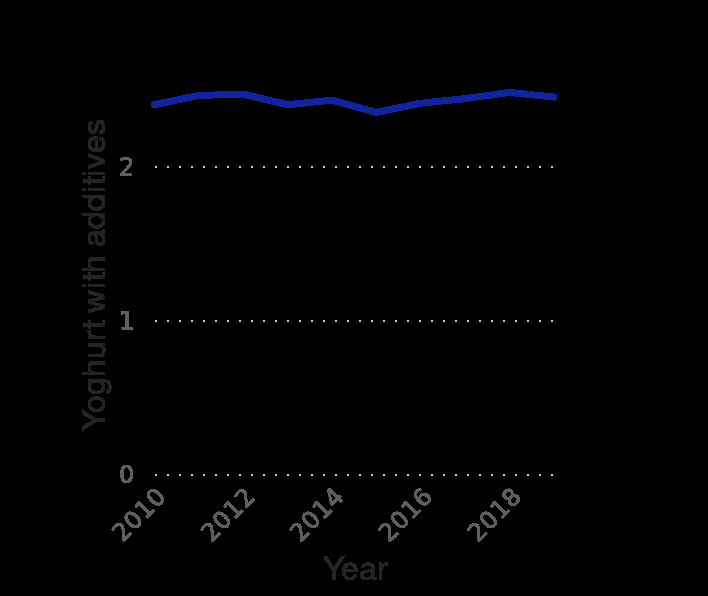<image>
Have there been any significant price increases or decreases in yoghurt? No, there have been no significant price increases or decreases in yoghurt. What has been the price trend of yoghurt over the years? The price of yoghurt has been stable across all years with little peaks but no major changes. 